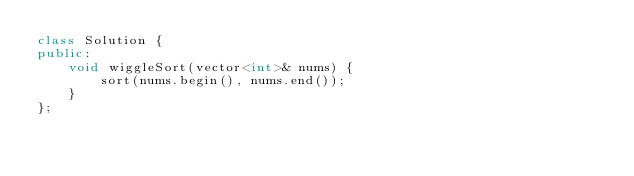<code> <loc_0><loc_0><loc_500><loc_500><_C++_>class Solution {
public:
    void wiggleSort(vector<int>& nums) {
        sort(nums.begin(), nums.end());
    }
};
</code> 